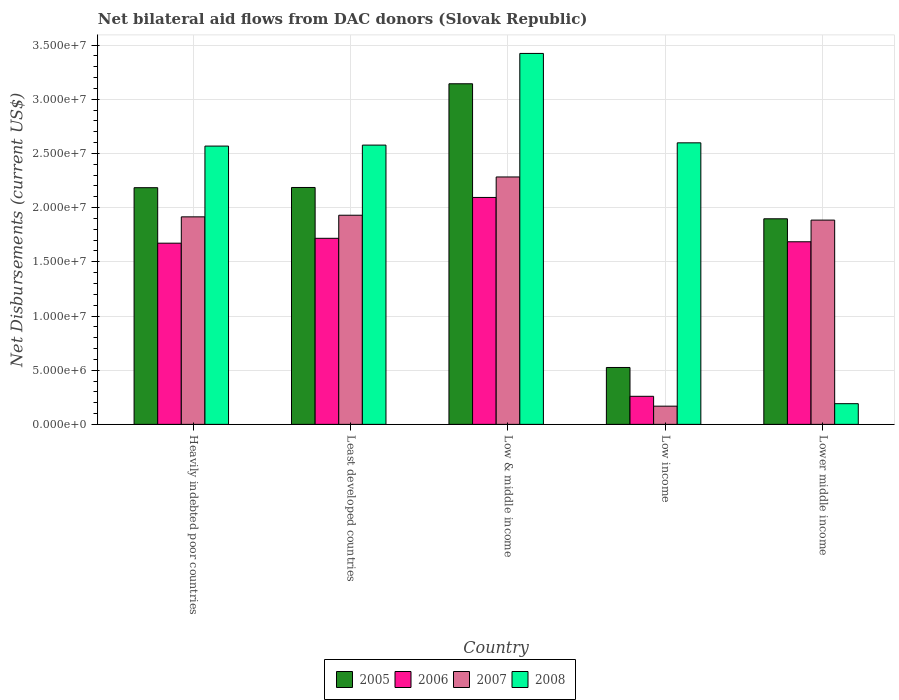How many different coloured bars are there?
Your response must be concise. 4. Are the number of bars on each tick of the X-axis equal?
Offer a terse response. Yes. What is the net bilateral aid flows in 2008 in Heavily indebted poor countries?
Make the answer very short. 2.57e+07. Across all countries, what is the maximum net bilateral aid flows in 2006?
Keep it short and to the point. 2.09e+07. Across all countries, what is the minimum net bilateral aid flows in 2005?
Give a very brief answer. 5.25e+06. In which country was the net bilateral aid flows in 2007 minimum?
Your answer should be very brief. Low income. What is the total net bilateral aid flows in 2007 in the graph?
Your response must be concise. 8.18e+07. What is the difference between the net bilateral aid flows in 2005 in Heavily indebted poor countries and the net bilateral aid flows in 2007 in Least developed countries?
Ensure brevity in your answer.  2.54e+06. What is the average net bilateral aid flows in 2008 per country?
Keep it short and to the point. 2.27e+07. What is the difference between the net bilateral aid flows of/in 2007 and net bilateral aid flows of/in 2008 in Least developed countries?
Ensure brevity in your answer.  -6.47e+06. In how many countries, is the net bilateral aid flows in 2006 greater than 15000000 US$?
Offer a very short reply. 4. What is the ratio of the net bilateral aid flows in 2008 in Heavily indebted poor countries to that in Least developed countries?
Give a very brief answer. 1. Is the net bilateral aid flows in 2008 in Low & middle income less than that in Lower middle income?
Your answer should be compact. No. Is the difference between the net bilateral aid flows in 2007 in Least developed countries and Lower middle income greater than the difference between the net bilateral aid flows in 2008 in Least developed countries and Lower middle income?
Give a very brief answer. No. What is the difference between the highest and the second highest net bilateral aid flows in 2005?
Offer a very short reply. 9.59e+06. What is the difference between the highest and the lowest net bilateral aid flows in 2006?
Your answer should be compact. 1.84e+07. In how many countries, is the net bilateral aid flows in 2006 greater than the average net bilateral aid flows in 2006 taken over all countries?
Provide a succinct answer. 4. Is it the case that in every country, the sum of the net bilateral aid flows in 2006 and net bilateral aid flows in 2007 is greater than the sum of net bilateral aid flows in 2008 and net bilateral aid flows in 2005?
Your answer should be compact. No. What does the 3rd bar from the right in Least developed countries represents?
Provide a short and direct response. 2006. Is it the case that in every country, the sum of the net bilateral aid flows in 2007 and net bilateral aid flows in 2005 is greater than the net bilateral aid flows in 2006?
Your answer should be very brief. Yes. How many bars are there?
Offer a very short reply. 20. Are all the bars in the graph horizontal?
Offer a terse response. No. How many countries are there in the graph?
Offer a terse response. 5. What is the title of the graph?
Ensure brevity in your answer.  Net bilateral aid flows from DAC donors (Slovak Republic). What is the label or title of the Y-axis?
Provide a short and direct response. Net Disbursements (current US$). What is the Net Disbursements (current US$) of 2005 in Heavily indebted poor countries?
Your answer should be compact. 2.18e+07. What is the Net Disbursements (current US$) of 2006 in Heavily indebted poor countries?
Make the answer very short. 1.67e+07. What is the Net Disbursements (current US$) of 2007 in Heavily indebted poor countries?
Your answer should be very brief. 1.92e+07. What is the Net Disbursements (current US$) of 2008 in Heavily indebted poor countries?
Your answer should be compact. 2.57e+07. What is the Net Disbursements (current US$) of 2005 in Least developed countries?
Offer a very short reply. 2.19e+07. What is the Net Disbursements (current US$) of 2006 in Least developed countries?
Offer a terse response. 1.72e+07. What is the Net Disbursements (current US$) of 2007 in Least developed countries?
Offer a terse response. 1.93e+07. What is the Net Disbursements (current US$) in 2008 in Least developed countries?
Offer a very short reply. 2.58e+07. What is the Net Disbursements (current US$) of 2005 in Low & middle income?
Keep it short and to the point. 3.14e+07. What is the Net Disbursements (current US$) of 2006 in Low & middle income?
Your answer should be very brief. 2.09e+07. What is the Net Disbursements (current US$) in 2007 in Low & middle income?
Offer a terse response. 2.28e+07. What is the Net Disbursements (current US$) of 2008 in Low & middle income?
Provide a succinct answer. 3.42e+07. What is the Net Disbursements (current US$) in 2005 in Low income?
Make the answer very short. 5.25e+06. What is the Net Disbursements (current US$) of 2006 in Low income?
Provide a short and direct response. 2.59e+06. What is the Net Disbursements (current US$) of 2007 in Low income?
Make the answer very short. 1.68e+06. What is the Net Disbursements (current US$) of 2008 in Low income?
Offer a terse response. 2.60e+07. What is the Net Disbursements (current US$) in 2005 in Lower middle income?
Your answer should be compact. 1.90e+07. What is the Net Disbursements (current US$) in 2006 in Lower middle income?
Ensure brevity in your answer.  1.68e+07. What is the Net Disbursements (current US$) in 2007 in Lower middle income?
Provide a short and direct response. 1.88e+07. What is the Net Disbursements (current US$) in 2008 in Lower middle income?
Provide a succinct answer. 1.91e+06. Across all countries, what is the maximum Net Disbursements (current US$) in 2005?
Keep it short and to the point. 3.14e+07. Across all countries, what is the maximum Net Disbursements (current US$) in 2006?
Keep it short and to the point. 2.09e+07. Across all countries, what is the maximum Net Disbursements (current US$) in 2007?
Offer a very short reply. 2.28e+07. Across all countries, what is the maximum Net Disbursements (current US$) of 2008?
Your response must be concise. 3.42e+07. Across all countries, what is the minimum Net Disbursements (current US$) in 2005?
Offer a terse response. 5.25e+06. Across all countries, what is the minimum Net Disbursements (current US$) in 2006?
Your response must be concise. 2.59e+06. Across all countries, what is the minimum Net Disbursements (current US$) in 2007?
Your answer should be compact. 1.68e+06. Across all countries, what is the minimum Net Disbursements (current US$) of 2008?
Your response must be concise. 1.91e+06. What is the total Net Disbursements (current US$) in 2005 in the graph?
Ensure brevity in your answer.  9.94e+07. What is the total Net Disbursements (current US$) of 2006 in the graph?
Your response must be concise. 7.43e+07. What is the total Net Disbursements (current US$) of 2007 in the graph?
Provide a short and direct response. 8.18e+07. What is the total Net Disbursements (current US$) of 2008 in the graph?
Offer a terse response. 1.14e+08. What is the difference between the Net Disbursements (current US$) of 2005 in Heavily indebted poor countries and that in Least developed countries?
Keep it short and to the point. -2.00e+04. What is the difference between the Net Disbursements (current US$) of 2006 in Heavily indebted poor countries and that in Least developed countries?
Offer a very short reply. -4.50e+05. What is the difference between the Net Disbursements (current US$) in 2005 in Heavily indebted poor countries and that in Low & middle income?
Make the answer very short. -9.59e+06. What is the difference between the Net Disbursements (current US$) of 2006 in Heavily indebted poor countries and that in Low & middle income?
Provide a short and direct response. -4.22e+06. What is the difference between the Net Disbursements (current US$) in 2007 in Heavily indebted poor countries and that in Low & middle income?
Give a very brief answer. -3.68e+06. What is the difference between the Net Disbursements (current US$) in 2008 in Heavily indebted poor countries and that in Low & middle income?
Offer a terse response. -8.55e+06. What is the difference between the Net Disbursements (current US$) in 2005 in Heavily indebted poor countries and that in Low income?
Offer a terse response. 1.66e+07. What is the difference between the Net Disbursements (current US$) in 2006 in Heavily indebted poor countries and that in Low income?
Provide a succinct answer. 1.41e+07. What is the difference between the Net Disbursements (current US$) in 2007 in Heavily indebted poor countries and that in Low income?
Your answer should be compact. 1.75e+07. What is the difference between the Net Disbursements (current US$) in 2008 in Heavily indebted poor countries and that in Low income?
Your answer should be very brief. -3.00e+05. What is the difference between the Net Disbursements (current US$) in 2005 in Heavily indebted poor countries and that in Lower middle income?
Your response must be concise. 2.87e+06. What is the difference between the Net Disbursements (current US$) of 2006 in Heavily indebted poor countries and that in Lower middle income?
Your answer should be very brief. -1.30e+05. What is the difference between the Net Disbursements (current US$) in 2008 in Heavily indebted poor countries and that in Lower middle income?
Your response must be concise. 2.38e+07. What is the difference between the Net Disbursements (current US$) in 2005 in Least developed countries and that in Low & middle income?
Offer a very short reply. -9.57e+06. What is the difference between the Net Disbursements (current US$) of 2006 in Least developed countries and that in Low & middle income?
Give a very brief answer. -3.77e+06. What is the difference between the Net Disbursements (current US$) in 2007 in Least developed countries and that in Low & middle income?
Offer a very short reply. -3.53e+06. What is the difference between the Net Disbursements (current US$) in 2008 in Least developed countries and that in Low & middle income?
Your answer should be compact. -8.46e+06. What is the difference between the Net Disbursements (current US$) in 2005 in Least developed countries and that in Low income?
Provide a short and direct response. 1.66e+07. What is the difference between the Net Disbursements (current US$) of 2006 in Least developed countries and that in Low income?
Offer a very short reply. 1.46e+07. What is the difference between the Net Disbursements (current US$) in 2007 in Least developed countries and that in Low income?
Keep it short and to the point. 1.76e+07. What is the difference between the Net Disbursements (current US$) in 2008 in Least developed countries and that in Low income?
Your answer should be very brief. -2.10e+05. What is the difference between the Net Disbursements (current US$) of 2005 in Least developed countries and that in Lower middle income?
Your answer should be very brief. 2.89e+06. What is the difference between the Net Disbursements (current US$) of 2008 in Least developed countries and that in Lower middle income?
Offer a terse response. 2.39e+07. What is the difference between the Net Disbursements (current US$) in 2005 in Low & middle income and that in Low income?
Your answer should be very brief. 2.62e+07. What is the difference between the Net Disbursements (current US$) in 2006 in Low & middle income and that in Low income?
Offer a very short reply. 1.84e+07. What is the difference between the Net Disbursements (current US$) in 2007 in Low & middle income and that in Low income?
Your answer should be compact. 2.12e+07. What is the difference between the Net Disbursements (current US$) of 2008 in Low & middle income and that in Low income?
Provide a short and direct response. 8.25e+06. What is the difference between the Net Disbursements (current US$) of 2005 in Low & middle income and that in Lower middle income?
Provide a succinct answer. 1.25e+07. What is the difference between the Net Disbursements (current US$) in 2006 in Low & middle income and that in Lower middle income?
Offer a terse response. 4.09e+06. What is the difference between the Net Disbursements (current US$) of 2007 in Low & middle income and that in Lower middle income?
Offer a terse response. 3.98e+06. What is the difference between the Net Disbursements (current US$) in 2008 in Low & middle income and that in Lower middle income?
Keep it short and to the point. 3.23e+07. What is the difference between the Net Disbursements (current US$) in 2005 in Low income and that in Lower middle income?
Make the answer very short. -1.37e+07. What is the difference between the Net Disbursements (current US$) in 2006 in Low income and that in Lower middle income?
Offer a terse response. -1.43e+07. What is the difference between the Net Disbursements (current US$) in 2007 in Low income and that in Lower middle income?
Your answer should be compact. -1.72e+07. What is the difference between the Net Disbursements (current US$) in 2008 in Low income and that in Lower middle income?
Provide a short and direct response. 2.41e+07. What is the difference between the Net Disbursements (current US$) in 2005 in Heavily indebted poor countries and the Net Disbursements (current US$) in 2006 in Least developed countries?
Offer a very short reply. 4.67e+06. What is the difference between the Net Disbursements (current US$) in 2005 in Heavily indebted poor countries and the Net Disbursements (current US$) in 2007 in Least developed countries?
Your answer should be very brief. 2.54e+06. What is the difference between the Net Disbursements (current US$) of 2005 in Heavily indebted poor countries and the Net Disbursements (current US$) of 2008 in Least developed countries?
Provide a succinct answer. -3.93e+06. What is the difference between the Net Disbursements (current US$) of 2006 in Heavily indebted poor countries and the Net Disbursements (current US$) of 2007 in Least developed countries?
Your response must be concise. -2.58e+06. What is the difference between the Net Disbursements (current US$) of 2006 in Heavily indebted poor countries and the Net Disbursements (current US$) of 2008 in Least developed countries?
Give a very brief answer. -9.05e+06. What is the difference between the Net Disbursements (current US$) in 2007 in Heavily indebted poor countries and the Net Disbursements (current US$) in 2008 in Least developed countries?
Make the answer very short. -6.62e+06. What is the difference between the Net Disbursements (current US$) in 2005 in Heavily indebted poor countries and the Net Disbursements (current US$) in 2007 in Low & middle income?
Keep it short and to the point. -9.90e+05. What is the difference between the Net Disbursements (current US$) of 2005 in Heavily indebted poor countries and the Net Disbursements (current US$) of 2008 in Low & middle income?
Provide a short and direct response. -1.24e+07. What is the difference between the Net Disbursements (current US$) of 2006 in Heavily indebted poor countries and the Net Disbursements (current US$) of 2007 in Low & middle income?
Your answer should be very brief. -6.11e+06. What is the difference between the Net Disbursements (current US$) in 2006 in Heavily indebted poor countries and the Net Disbursements (current US$) in 2008 in Low & middle income?
Make the answer very short. -1.75e+07. What is the difference between the Net Disbursements (current US$) of 2007 in Heavily indebted poor countries and the Net Disbursements (current US$) of 2008 in Low & middle income?
Ensure brevity in your answer.  -1.51e+07. What is the difference between the Net Disbursements (current US$) in 2005 in Heavily indebted poor countries and the Net Disbursements (current US$) in 2006 in Low income?
Provide a short and direct response. 1.92e+07. What is the difference between the Net Disbursements (current US$) of 2005 in Heavily indebted poor countries and the Net Disbursements (current US$) of 2007 in Low income?
Provide a succinct answer. 2.02e+07. What is the difference between the Net Disbursements (current US$) in 2005 in Heavily indebted poor countries and the Net Disbursements (current US$) in 2008 in Low income?
Your answer should be compact. -4.14e+06. What is the difference between the Net Disbursements (current US$) of 2006 in Heavily indebted poor countries and the Net Disbursements (current US$) of 2007 in Low income?
Give a very brief answer. 1.50e+07. What is the difference between the Net Disbursements (current US$) in 2006 in Heavily indebted poor countries and the Net Disbursements (current US$) in 2008 in Low income?
Give a very brief answer. -9.26e+06. What is the difference between the Net Disbursements (current US$) of 2007 in Heavily indebted poor countries and the Net Disbursements (current US$) of 2008 in Low income?
Offer a very short reply. -6.83e+06. What is the difference between the Net Disbursements (current US$) of 2005 in Heavily indebted poor countries and the Net Disbursements (current US$) of 2006 in Lower middle income?
Give a very brief answer. 4.99e+06. What is the difference between the Net Disbursements (current US$) of 2005 in Heavily indebted poor countries and the Net Disbursements (current US$) of 2007 in Lower middle income?
Give a very brief answer. 2.99e+06. What is the difference between the Net Disbursements (current US$) in 2005 in Heavily indebted poor countries and the Net Disbursements (current US$) in 2008 in Lower middle income?
Your response must be concise. 1.99e+07. What is the difference between the Net Disbursements (current US$) of 2006 in Heavily indebted poor countries and the Net Disbursements (current US$) of 2007 in Lower middle income?
Provide a short and direct response. -2.13e+06. What is the difference between the Net Disbursements (current US$) of 2006 in Heavily indebted poor countries and the Net Disbursements (current US$) of 2008 in Lower middle income?
Offer a very short reply. 1.48e+07. What is the difference between the Net Disbursements (current US$) in 2007 in Heavily indebted poor countries and the Net Disbursements (current US$) in 2008 in Lower middle income?
Give a very brief answer. 1.72e+07. What is the difference between the Net Disbursements (current US$) in 2005 in Least developed countries and the Net Disbursements (current US$) in 2006 in Low & middle income?
Give a very brief answer. 9.20e+05. What is the difference between the Net Disbursements (current US$) in 2005 in Least developed countries and the Net Disbursements (current US$) in 2007 in Low & middle income?
Your response must be concise. -9.70e+05. What is the difference between the Net Disbursements (current US$) of 2005 in Least developed countries and the Net Disbursements (current US$) of 2008 in Low & middle income?
Ensure brevity in your answer.  -1.24e+07. What is the difference between the Net Disbursements (current US$) in 2006 in Least developed countries and the Net Disbursements (current US$) in 2007 in Low & middle income?
Your answer should be very brief. -5.66e+06. What is the difference between the Net Disbursements (current US$) of 2006 in Least developed countries and the Net Disbursements (current US$) of 2008 in Low & middle income?
Make the answer very short. -1.71e+07. What is the difference between the Net Disbursements (current US$) in 2007 in Least developed countries and the Net Disbursements (current US$) in 2008 in Low & middle income?
Your answer should be very brief. -1.49e+07. What is the difference between the Net Disbursements (current US$) of 2005 in Least developed countries and the Net Disbursements (current US$) of 2006 in Low income?
Your answer should be very brief. 1.93e+07. What is the difference between the Net Disbursements (current US$) in 2005 in Least developed countries and the Net Disbursements (current US$) in 2007 in Low income?
Your answer should be very brief. 2.02e+07. What is the difference between the Net Disbursements (current US$) in 2005 in Least developed countries and the Net Disbursements (current US$) in 2008 in Low income?
Your answer should be very brief. -4.12e+06. What is the difference between the Net Disbursements (current US$) in 2006 in Least developed countries and the Net Disbursements (current US$) in 2007 in Low income?
Your response must be concise. 1.55e+07. What is the difference between the Net Disbursements (current US$) in 2006 in Least developed countries and the Net Disbursements (current US$) in 2008 in Low income?
Your answer should be very brief. -8.81e+06. What is the difference between the Net Disbursements (current US$) in 2007 in Least developed countries and the Net Disbursements (current US$) in 2008 in Low income?
Your answer should be compact. -6.68e+06. What is the difference between the Net Disbursements (current US$) in 2005 in Least developed countries and the Net Disbursements (current US$) in 2006 in Lower middle income?
Offer a terse response. 5.01e+06. What is the difference between the Net Disbursements (current US$) of 2005 in Least developed countries and the Net Disbursements (current US$) of 2007 in Lower middle income?
Offer a very short reply. 3.01e+06. What is the difference between the Net Disbursements (current US$) in 2005 in Least developed countries and the Net Disbursements (current US$) in 2008 in Lower middle income?
Provide a short and direct response. 2.00e+07. What is the difference between the Net Disbursements (current US$) in 2006 in Least developed countries and the Net Disbursements (current US$) in 2007 in Lower middle income?
Provide a succinct answer. -1.68e+06. What is the difference between the Net Disbursements (current US$) of 2006 in Least developed countries and the Net Disbursements (current US$) of 2008 in Lower middle income?
Offer a terse response. 1.53e+07. What is the difference between the Net Disbursements (current US$) in 2007 in Least developed countries and the Net Disbursements (current US$) in 2008 in Lower middle income?
Your answer should be very brief. 1.74e+07. What is the difference between the Net Disbursements (current US$) in 2005 in Low & middle income and the Net Disbursements (current US$) in 2006 in Low income?
Provide a succinct answer. 2.88e+07. What is the difference between the Net Disbursements (current US$) in 2005 in Low & middle income and the Net Disbursements (current US$) in 2007 in Low income?
Make the answer very short. 2.98e+07. What is the difference between the Net Disbursements (current US$) in 2005 in Low & middle income and the Net Disbursements (current US$) in 2008 in Low income?
Make the answer very short. 5.45e+06. What is the difference between the Net Disbursements (current US$) in 2006 in Low & middle income and the Net Disbursements (current US$) in 2007 in Low income?
Your answer should be very brief. 1.93e+07. What is the difference between the Net Disbursements (current US$) of 2006 in Low & middle income and the Net Disbursements (current US$) of 2008 in Low income?
Offer a terse response. -5.04e+06. What is the difference between the Net Disbursements (current US$) in 2007 in Low & middle income and the Net Disbursements (current US$) in 2008 in Low income?
Offer a very short reply. -3.15e+06. What is the difference between the Net Disbursements (current US$) of 2005 in Low & middle income and the Net Disbursements (current US$) of 2006 in Lower middle income?
Make the answer very short. 1.46e+07. What is the difference between the Net Disbursements (current US$) in 2005 in Low & middle income and the Net Disbursements (current US$) in 2007 in Lower middle income?
Ensure brevity in your answer.  1.26e+07. What is the difference between the Net Disbursements (current US$) of 2005 in Low & middle income and the Net Disbursements (current US$) of 2008 in Lower middle income?
Give a very brief answer. 2.95e+07. What is the difference between the Net Disbursements (current US$) in 2006 in Low & middle income and the Net Disbursements (current US$) in 2007 in Lower middle income?
Provide a succinct answer. 2.09e+06. What is the difference between the Net Disbursements (current US$) of 2006 in Low & middle income and the Net Disbursements (current US$) of 2008 in Lower middle income?
Make the answer very short. 1.90e+07. What is the difference between the Net Disbursements (current US$) of 2007 in Low & middle income and the Net Disbursements (current US$) of 2008 in Lower middle income?
Give a very brief answer. 2.09e+07. What is the difference between the Net Disbursements (current US$) in 2005 in Low income and the Net Disbursements (current US$) in 2006 in Lower middle income?
Offer a terse response. -1.16e+07. What is the difference between the Net Disbursements (current US$) in 2005 in Low income and the Net Disbursements (current US$) in 2007 in Lower middle income?
Your response must be concise. -1.36e+07. What is the difference between the Net Disbursements (current US$) of 2005 in Low income and the Net Disbursements (current US$) of 2008 in Lower middle income?
Make the answer very short. 3.34e+06. What is the difference between the Net Disbursements (current US$) of 2006 in Low income and the Net Disbursements (current US$) of 2007 in Lower middle income?
Your answer should be compact. -1.63e+07. What is the difference between the Net Disbursements (current US$) of 2006 in Low income and the Net Disbursements (current US$) of 2008 in Lower middle income?
Make the answer very short. 6.80e+05. What is the average Net Disbursements (current US$) in 2005 per country?
Offer a very short reply. 1.99e+07. What is the average Net Disbursements (current US$) of 2006 per country?
Keep it short and to the point. 1.49e+07. What is the average Net Disbursements (current US$) in 2007 per country?
Offer a terse response. 1.64e+07. What is the average Net Disbursements (current US$) of 2008 per country?
Your answer should be compact. 2.27e+07. What is the difference between the Net Disbursements (current US$) of 2005 and Net Disbursements (current US$) of 2006 in Heavily indebted poor countries?
Make the answer very short. 5.12e+06. What is the difference between the Net Disbursements (current US$) of 2005 and Net Disbursements (current US$) of 2007 in Heavily indebted poor countries?
Keep it short and to the point. 2.69e+06. What is the difference between the Net Disbursements (current US$) of 2005 and Net Disbursements (current US$) of 2008 in Heavily indebted poor countries?
Provide a succinct answer. -3.84e+06. What is the difference between the Net Disbursements (current US$) in 2006 and Net Disbursements (current US$) in 2007 in Heavily indebted poor countries?
Provide a succinct answer. -2.43e+06. What is the difference between the Net Disbursements (current US$) in 2006 and Net Disbursements (current US$) in 2008 in Heavily indebted poor countries?
Your answer should be very brief. -8.96e+06. What is the difference between the Net Disbursements (current US$) of 2007 and Net Disbursements (current US$) of 2008 in Heavily indebted poor countries?
Provide a succinct answer. -6.53e+06. What is the difference between the Net Disbursements (current US$) in 2005 and Net Disbursements (current US$) in 2006 in Least developed countries?
Keep it short and to the point. 4.69e+06. What is the difference between the Net Disbursements (current US$) of 2005 and Net Disbursements (current US$) of 2007 in Least developed countries?
Make the answer very short. 2.56e+06. What is the difference between the Net Disbursements (current US$) of 2005 and Net Disbursements (current US$) of 2008 in Least developed countries?
Provide a short and direct response. -3.91e+06. What is the difference between the Net Disbursements (current US$) of 2006 and Net Disbursements (current US$) of 2007 in Least developed countries?
Your answer should be compact. -2.13e+06. What is the difference between the Net Disbursements (current US$) in 2006 and Net Disbursements (current US$) in 2008 in Least developed countries?
Your answer should be very brief. -8.60e+06. What is the difference between the Net Disbursements (current US$) in 2007 and Net Disbursements (current US$) in 2008 in Least developed countries?
Your response must be concise. -6.47e+06. What is the difference between the Net Disbursements (current US$) in 2005 and Net Disbursements (current US$) in 2006 in Low & middle income?
Keep it short and to the point. 1.05e+07. What is the difference between the Net Disbursements (current US$) in 2005 and Net Disbursements (current US$) in 2007 in Low & middle income?
Your answer should be very brief. 8.60e+06. What is the difference between the Net Disbursements (current US$) of 2005 and Net Disbursements (current US$) of 2008 in Low & middle income?
Your answer should be very brief. -2.80e+06. What is the difference between the Net Disbursements (current US$) of 2006 and Net Disbursements (current US$) of 2007 in Low & middle income?
Make the answer very short. -1.89e+06. What is the difference between the Net Disbursements (current US$) in 2006 and Net Disbursements (current US$) in 2008 in Low & middle income?
Offer a very short reply. -1.33e+07. What is the difference between the Net Disbursements (current US$) in 2007 and Net Disbursements (current US$) in 2008 in Low & middle income?
Ensure brevity in your answer.  -1.14e+07. What is the difference between the Net Disbursements (current US$) in 2005 and Net Disbursements (current US$) in 2006 in Low income?
Provide a succinct answer. 2.66e+06. What is the difference between the Net Disbursements (current US$) of 2005 and Net Disbursements (current US$) of 2007 in Low income?
Your response must be concise. 3.57e+06. What is the difference between the Net Disbursements (current US$) of 2005 and Net Disbursements (current US$) of 2008 in Low income?
Your answer should be very brief. -2.07e+07. What is the difference between the Net Disbursements (current US$) of 2006 and Net Disbursements (current US$) of 2007 in Low income?
Offer a very short reply. 9.10e+05. What is the difference between the Net Disbursements (current US$) of 2006 and Net Disbursements (current US$) of 2008 in Low income?
Offer a very short reply. -2.34e+07. What is the difference between the Net Disbursements (current US$) in 2007 and Net Disbursements (current US$) in 2008 in Low income?
Give a very brief answer. -2.43e+07. What is the difference between the Net Disbursements (current US$) in 2005 and Net Disbursements (current US$) in 2006 in Lower middle income?
Your response must be concise. 2.12e+06. What is the difference between the Net Disbursements (current US$) in 2005 and Net Disbursements (current US$) in 2007 in Lower middle income?
Provide a succinct answer. 1.20e+05. What is the difference between the Net Disbursements (current US$) in 2005 and Net Disbursements (current US$) in 2008 in Lower middle income?
Ensure brevity in your answer.  1.71e+07. What is the difference between the Net Disbursements (current US$) of 2006 and Net Disbursements (current US$) of 2008 in Lower middle income?
Ensure brevity in your answer.  1.49e+07. What is the difference between the Net Disbursements (current US$) of 2007 and Net Disbursements (current US$) of 2008 in Lower middle income?
Your answer should be compact. 1.69e+07. What is the ratio of the Net Disbursements (current US$) of 2005 in Heavily indebted poor countries to that in Least developed countries?
Your response must be concise. 1. What is the ratio of the Net Disbursements (current US$) of 2006 in Heavily indebted poor countries to that in Least developed countries?
Your answer should be very brief. 0.97. What is the ratio of the Net Disbursements (current US$) in 2007 in Heavily indebted poor countries to that in Least developed countries?
Provide a succinct answer. 0.99. What is the ratio of the Net Disbursements (current US$) in 2005 in Heavily indebted poor countries to that in Low & middle income?
Offer a very short reply. 0.69. What is the ratio of the Net Disbursements (current US$) of 2006 in Heavily indebted poor countries to that in Low & middle income?
Make the answer very short. 0.8. What is the ratio of the Net Disbursements (current US$) of 2007 in Heavily indebted poor countries to that in Low & middle income?
Ensure brevity in your answer.  0.84. What is the ratio of the Net Disbursements (current US$) of 2008 in Heavily indebted poor countries to that in Low & middle income?
Give a very brief answer. 0.75. What is the ratio of the Net Disbursements (current US$) in 2005 in Heavily indebted poor countries to that in Low income?
Ensure brevity in your answer.  4.16. What is the ratio of the Net Disbursements (current US$) of 2006 in Heavily indebted poor countries to that in Low income?
Make the answer very short. 6.46. What is the ratio of the Net Disbursements (current US$) of 2007 in Heavily indebted poor countries to that in Low income?
Your answer should be very brief. 11.4. What is the ratio of the Net Disbursements (current US$) of 2005 in Heavily indebted poor countries to that in Lower middle income?
Provide a succinct answer. 1.15. What is the ratio of the Net Disbursements (current US$) in 2007 in Heavily indebted poor countries to that in Lower middle income?
Make the answer very short. 1.02. What is the ratio of the Net Disbursements (current US$) of 2008 in Heavily indebted poor countries to that in Lower middle income?
Your answer should be compact. 13.45. What is the ratio of the Net Disbursements (current US$) in 2005 in Least developed countries to that in Low & middle income?
Keep it short and to the point. 0.7. What is the ratio of the Net Disbursements (current US$) in 2006 in Least developed countries to that in Low & middle income?
Your response must be concise. 0.82. What is the ratio of the Net Disbursements (current US$) in 2007 in Least developed countries to that in Low & middle income?
Ensure brevity in your answer.  0.85. What is the ratio of the Net Disbursements (current US$) of 2008 in Least developed countries to that in Low & middle income?
Offer a very short reply. 0.75. What is the ratio of the Net Disbursements (current US$) of 2005 in Least developed countries to that in Low income?
Keep it short and to the point. 4.16. What is the ratio of the Net Disbursements (current US$) of 2006 in Least developed countries to that in Low income?
Offer a terse response. 6.63. What is the ratio of the Net Disbursements (current US$) in 2007 in Least developed countries to that in Low income?
Give a very brief answer. 11.49. What is the ratio of the Net Disbursements (current US$) in 2005 in Least developed countries to that in Lower middle income?
Ensure brevity in your answer.  1.15. What is the ratio of the Net Disbursements (current US$) in 2006 in Least developed countries to that in Lower middle income?
Offer a terse response. 1.02. What is the ratio of the Net Disbursements (current US$) in 2007 in Least developed countries to that in Lower middle income?
Offer a very short reply. 1.02. What is the ratio of the Net Disbursements (current US$) in 2008 in Least developed countries to that in Lower middle income?
Your answer should be compact. 13.49. What is the ratio of the Net Disbursements (current US$) in 2005 in Low & middle income to that in Low income?
Offer a terse response. 5.99. What is the ratio of the Net Disbursements (current US$) of 2006 in Low & middle income to that in Low income?
Offer a terse response. 8.08. What is the ratio of the Net Disbursements (current US$) in 2007 in Low & middle income to that in Low income?
Ensure brevity in your answer.  13.59. What is the ratio of the Net Disbursements (current US$) in 2008 in Low & middle income to that in Low income?
Keep it short and to the point. 1.32. What is the ratio of the Net Disbursements (current US$) of 2005 in Low & middle income to that in Lower middle income?
Provide a short and direct response. 1.66. What is the ratio of the Net Disbursements (current US$) of 2006 in Low & middle income to that in Lower middle income?
Provide a short and direct response. 1.24. What is the ratio of the Net Disbursements (current US$) of 2007 in Low & middle income to that in Lower middle income?
Your answer should be compact. 1.21. What is the ratio of the Net Disbursements (current US$) of 2008 in Low & middle income to that in Lower middle income?
Ensure brevity in your answer.  17.92. What is the ratio of the Net Disbursements (current US$) of 2005 in Low income to that in Lower middle income?
Your answer should be very brief. 0.28. What is the ratio of the Net Disbursements (current US$) of 2006 in Low income to that in Lower middle income?
Offer a very short reply. 0.15. What is the ratio of the Net Disbursements (current US$) in 2007 in Low income to that in Lower middle income?
Make the answer very short. 0.09. What is the ratio of the Net Disbursements (current US$) in 2008 in Low income to that in Lower middle income?
Provide a short and direct response. 13.6. What is the difference between the highest and the second highest Net Disbursements (current US$) in 2005?
Provide a short and direct response. 9.57e+06. What is the difference between the highest and the second highest Net Disbursements (current US$) in 2006?
Provide a succinct answer. 3.77e+06. What is the difference between the highest and the second highest Net Disbursements (current US$) of 2007?
Offer a terse response. 3.53e+06. What is the difference between the highest and the second highest Net Disbursements (current US$) of 2008?
Your answer should be very brief. 8.25e+06. What is the difference between the highest and the lowest Net Disbursements (current US$) in 2005?
Ensure brevity in your answer.  2.62e+07. What is the difference between the highest and the lowest Net Disbursements (current US$) of 2006?
Your answer should be very brief. 1.84e+07. What is the difference between the highest and the lowest Net Disbursements (current US$) of 2007?
Ensure brevity in your answer.  2.12e+07. What is the difference between the highest and the lowest Net Disbursements (current US$) in 2008?
Your answer should be compact. 3.23e+07. 